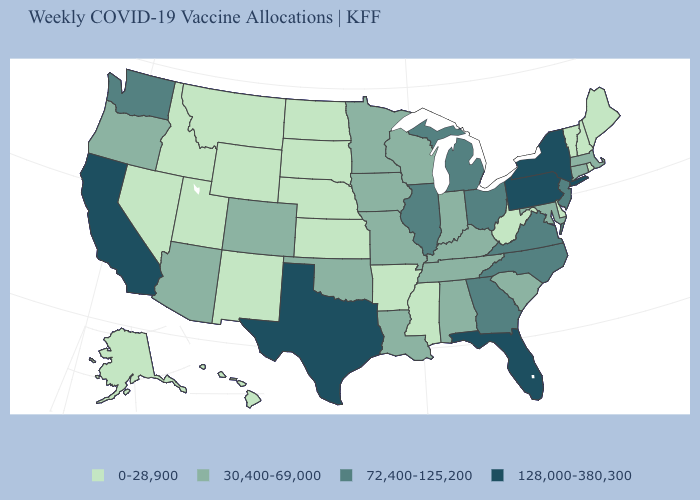Name the states that have a value in the range 30,400-69,000?
Answer briefly. Alabama, Arizona, Colorado, Connecticut, Indiana, Iowa, Kentucky, Louisiana, Maryland, Massachusetts, Minnesota, Missouri, Oklahoma, Oregon, South Carolina, Tennessee, Wisconsin. Does Florida have the highest value in the South?
Concise answer only. Yes. Does the first symbol in the legend represent the smallest category?
Quick response, please. Yes. Which states have the lowest value in the USA?
Quick response, please. Alaska, Arkansas, Delaware, Hawaii, Idaho, Kansas, Maine, Mississippi, Montana, Nebraska, Nevada, New Hampshire, New Mexico, North Dakota, Rhode Island, South Dakota, Utah, Vermont, West Virginia, Wyoming. Does the map have missing data?
Write a very short answer. No. Name the states that have a value in the range 30,400-69,000?
Quick response, please. Alabama, Arizona, Colorado, Connecticut, Indiana, Iowa, Kentucky, Louisiana, Maryland, Massachusetts, Minnesota, Missouri, Oklahoma, Oregon, South Carolina, Tennessee, Wisconsin. Name the states that have a value in the range 30,400-69,000?
Answer briefly. Alabama, Arizona, Colorado, Connecticut, Indiana, Iowa, Kentucky, Louisiana, Maryland, Massachusetts, Minnesota, Missouri, Oklahoma, Oregon, South Carolina, Tennessee, Wisconsin. Name the states that have a value in the range 30,400-69,000?
Short answer required. Alabama, Arizona, Colorado, Connecticut, Indiana, Iowa, Kentucky, Louisiana, Maryland, Massachusetts, Minnesota, Missouri, Oklahoma, Oregon, South Carolina, Tennessee, Wisconsin. What is the value of Vermont?
Short answer required. 0-28,900. Does North Carolina have the lowest value in the USA?
Give a very brief answer. No. Which states have the lowest value in the USA?
Write a very short answer. Alaska, Arkansas, Delaware, Hawaii, Idaho, Kansas, Maine, Mississippi, Montana, Nebraska, Nevada, New Hampshire, New Mexico, North Dakota, Rhode Island, South Dakota, Utah, Vermont, West Virginia, Wyoming. What is the value of Arkansas?
Answer briefly. 0-28,900. Does South Carolina have the lowest value in the USA?
Concise answer only. No. Name the states that have a value in the range 30,400-69,000?
Quick response, please. Alabama, Arizona, Colorado, Connecticut, Indiana, Iowa, Kentucky, Louisiana, Maryland, Massachusetts, Minnesota, Missouri, Oklahoma, Oregon, South Carolina, Tennessee, Wisconsin. What is the value of Vermont?
Be succinct. 0-28,900. 